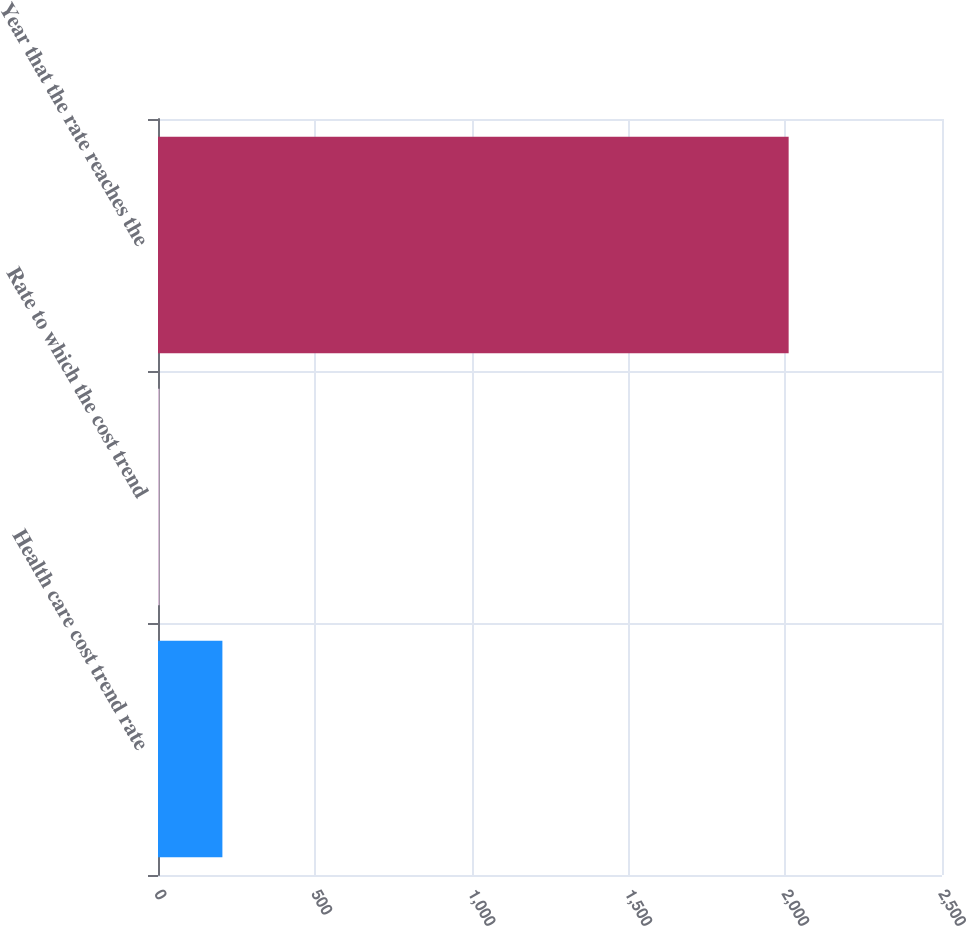Convert chart. <chart><loc_0><loc_0><loc_500><loc_500><bar_chart><fcel>Health care cost trend rate<fcel>Rate to which the cost trend<fcel>Year that the rate reaches the<nl><fcel>205.33<fcel>4.7<fcel>2011<nl></chart> 